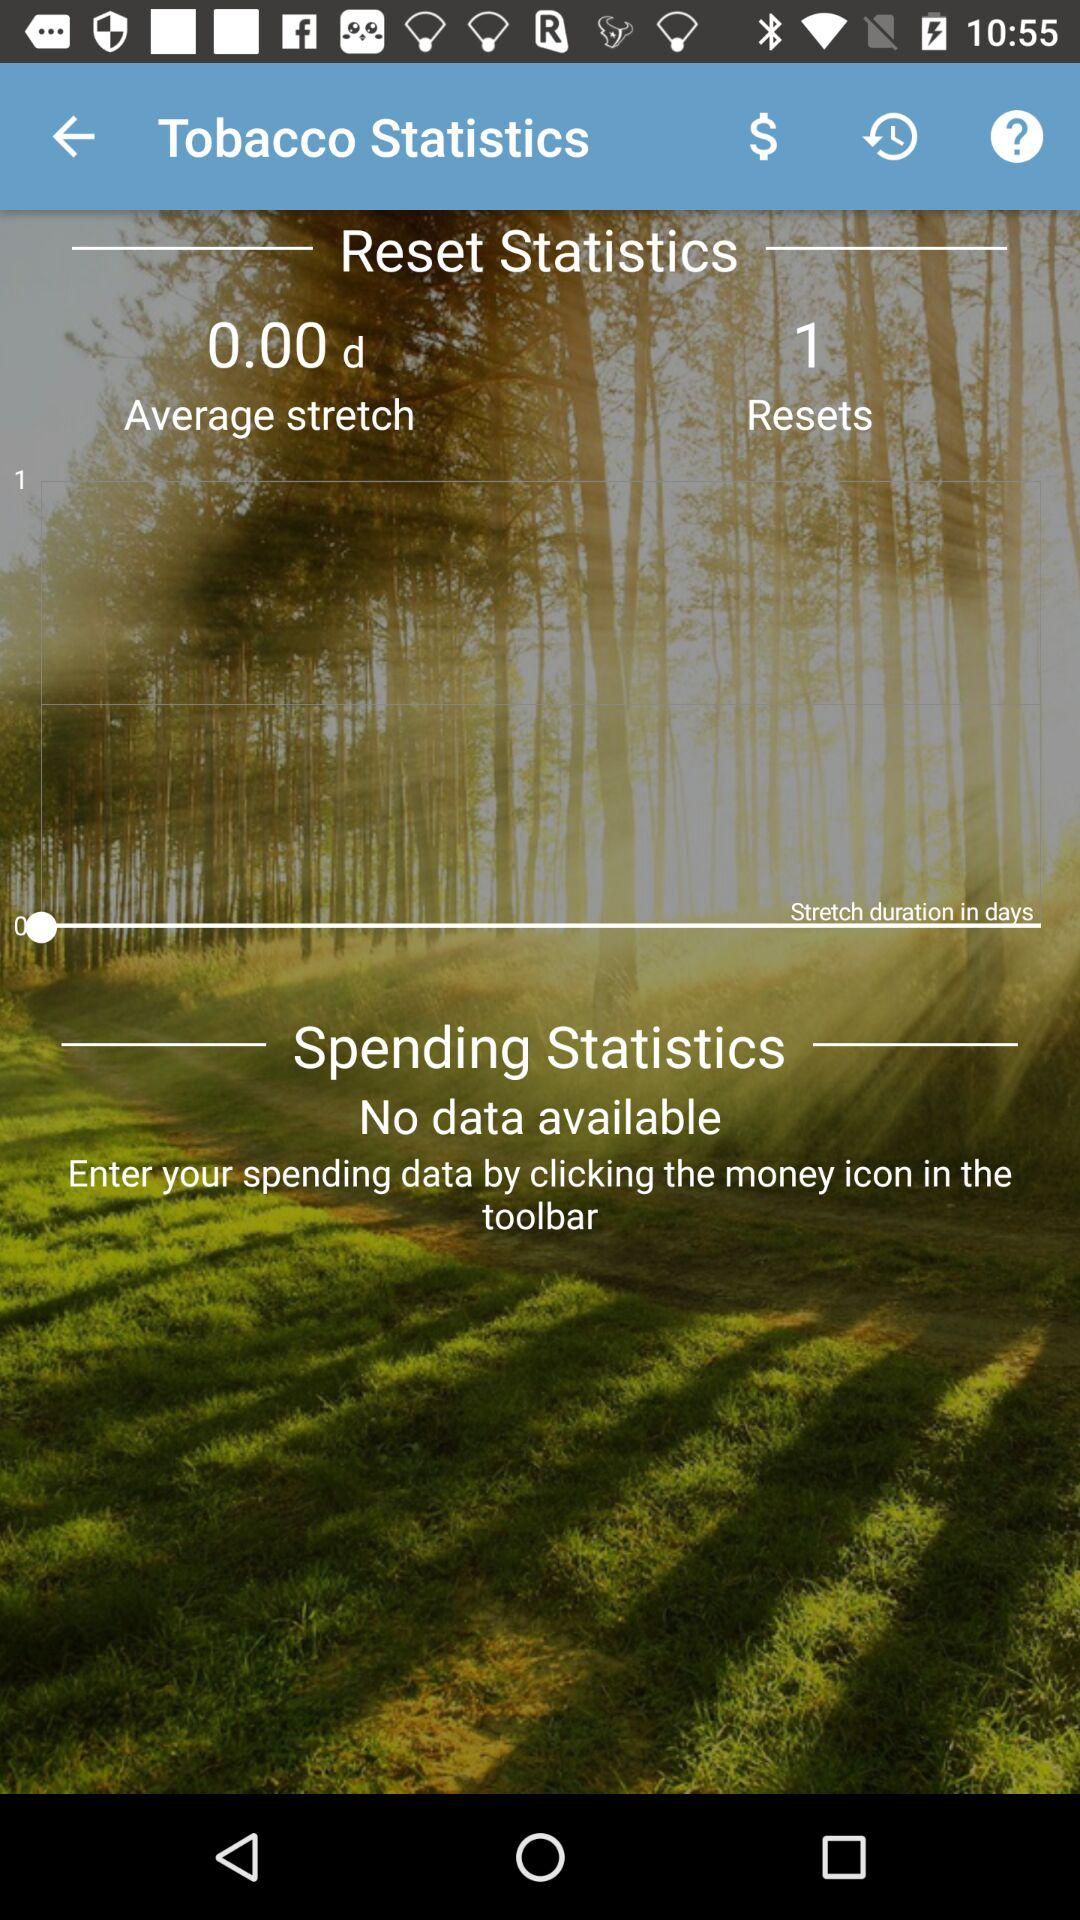What is the average stretch? The average stretch is 0 d. 